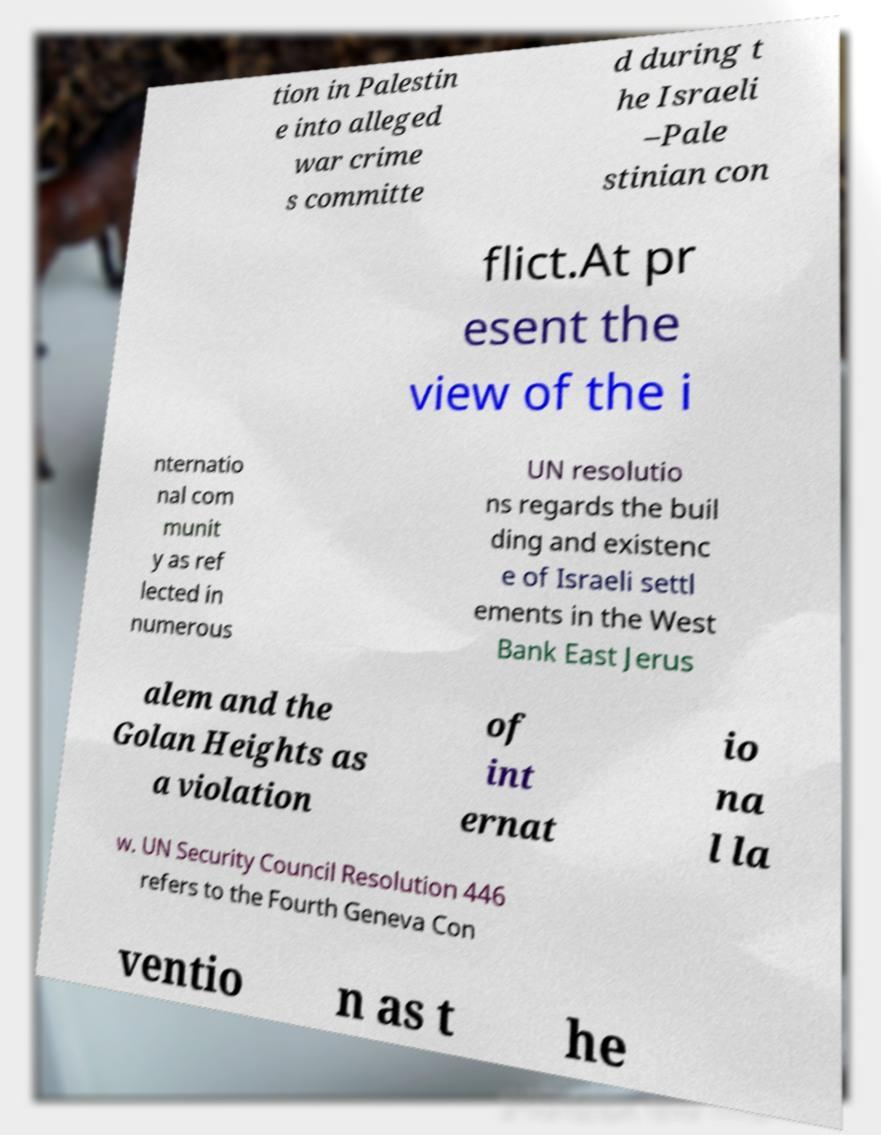Could you assist in decoding the text presented in this image and type it out clearly? tion in Palestin e into alleged war crime s committe d during t he Israeli –Pale stinian con flict.At pr esent the view of the i nternatio nal com munit y as ref lected in numerous UN resolutio ns regards the buil ding and existenc e of Israeli settl ements in the West Bank East Jerus alem and the Golan Heights as a violation of int ernat io na l la w. UN Security Council Resolution 446 refers to the Fourth Geneva Con ventio n as t he 